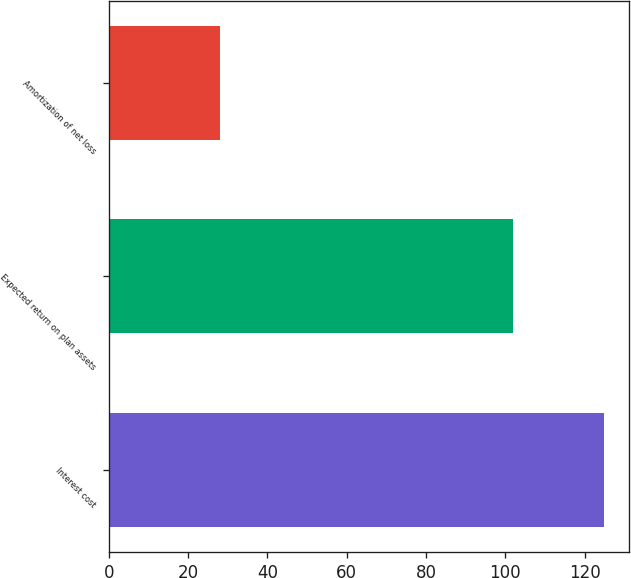Convert chart to OTSL. <chart><loc_0><loc_0><loc_500><loc_500><bar_chart><fcel>Interest cost<fcel>Expected return on plan assets<fcel>Amortization of net loss<nl><fcel>125<fcel>102<fcel>28<nl></chart> 